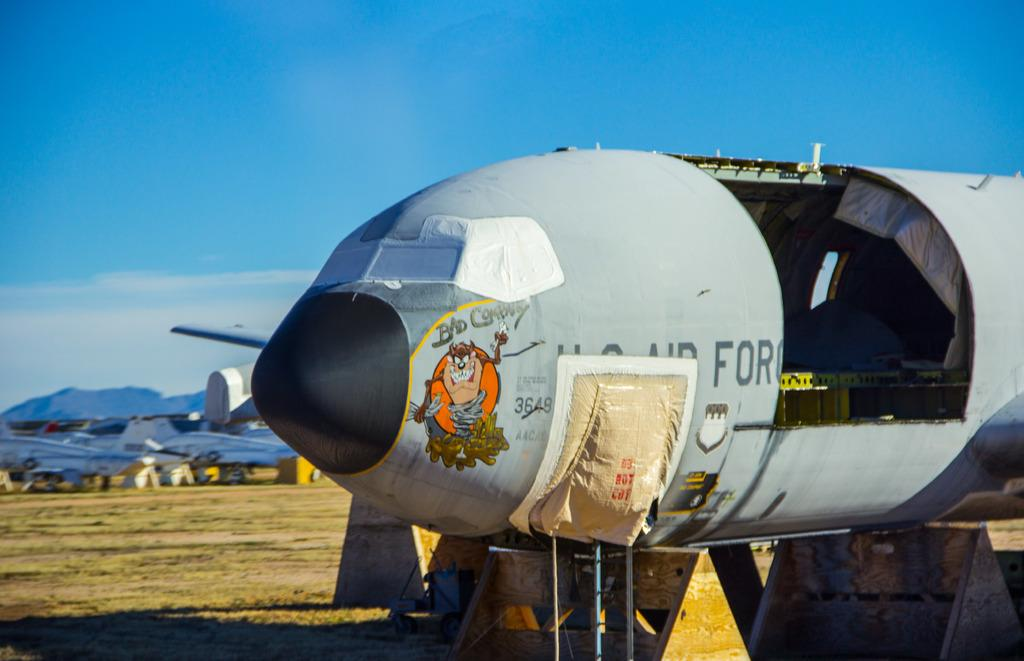<image>
Give a short and clear explanation of the subsequent image. An aircraft in mid-repair features a Tasmanian Devil representation under the phrase "Bad Company". 